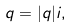Convert formula to latex. <formula><loc_0><loc_0><loc_500><loc_500>q = | q | i ,</formula> 